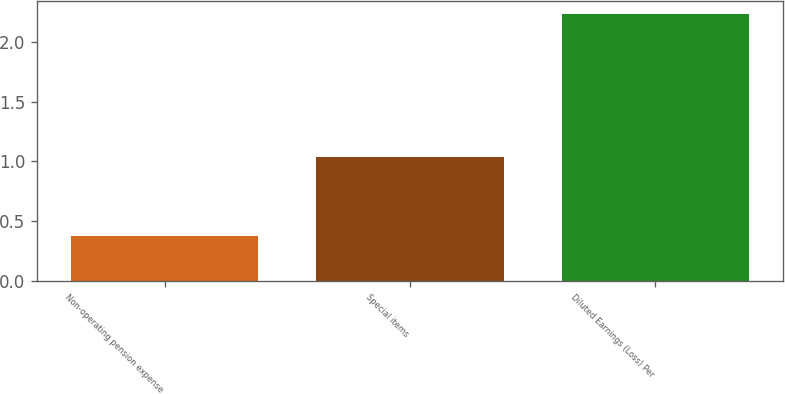<chart> <loc_0><loc_0><loc_500><loc_500><bar_chart><fcel>Non-operating pension expense<fcel>Special items<fcel>Diluted Earnings (Loss) Per<nl><fcel>0.38<fcel>1.04<fcel>2.23<nl></chart> 